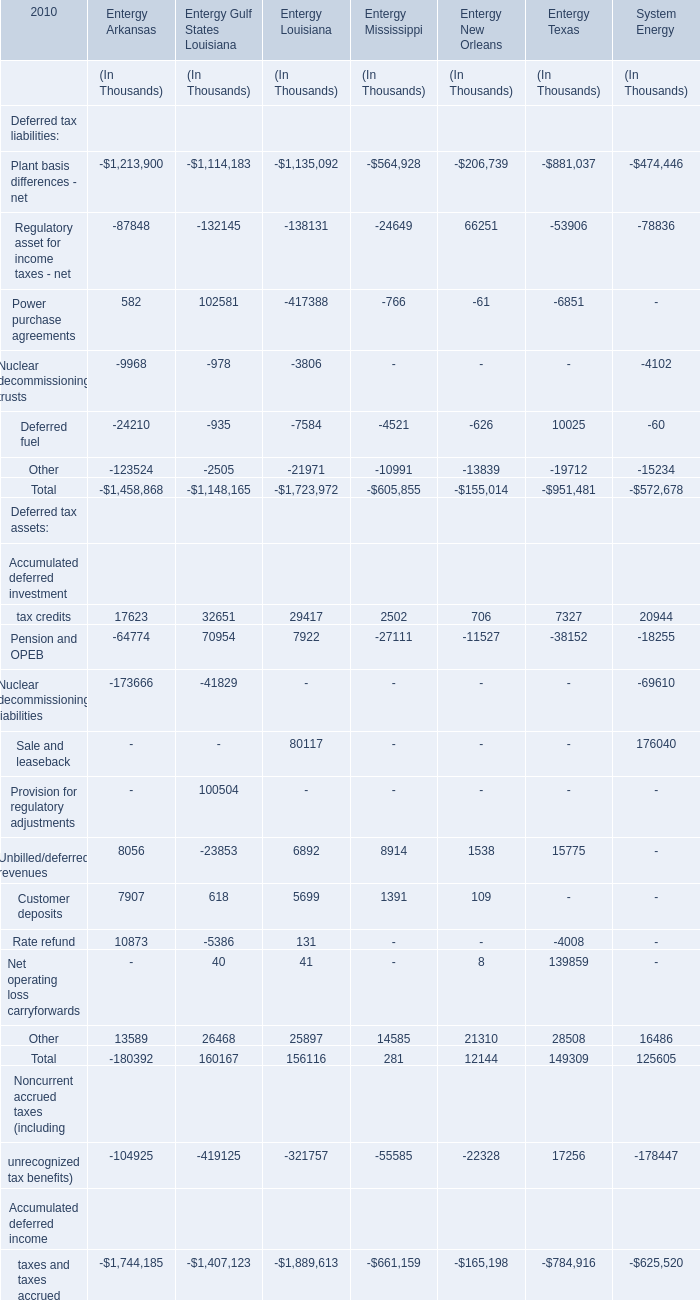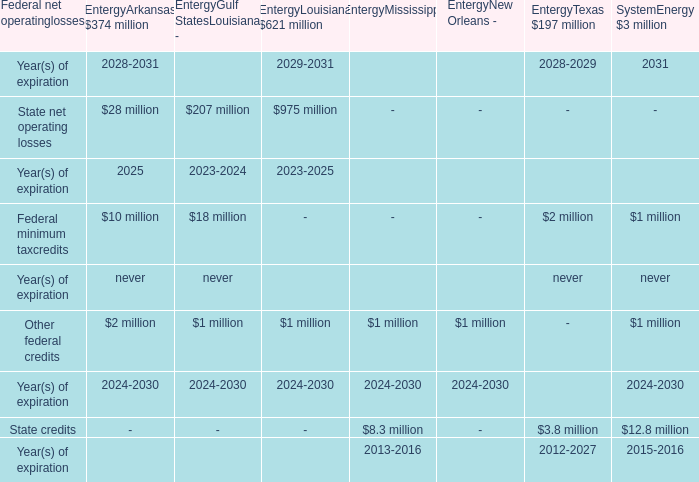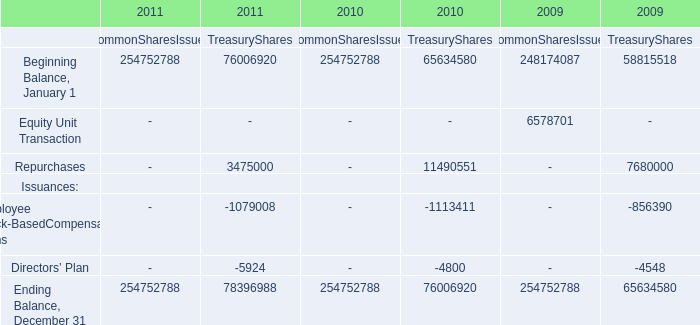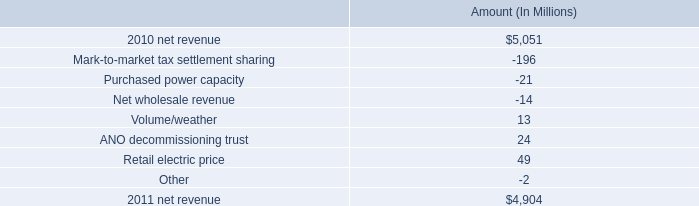what is the total amount of variance that favorably affected net revenue in 2011? 
Computations: ((13 + 24) + 49)
Answer: 86.0. 